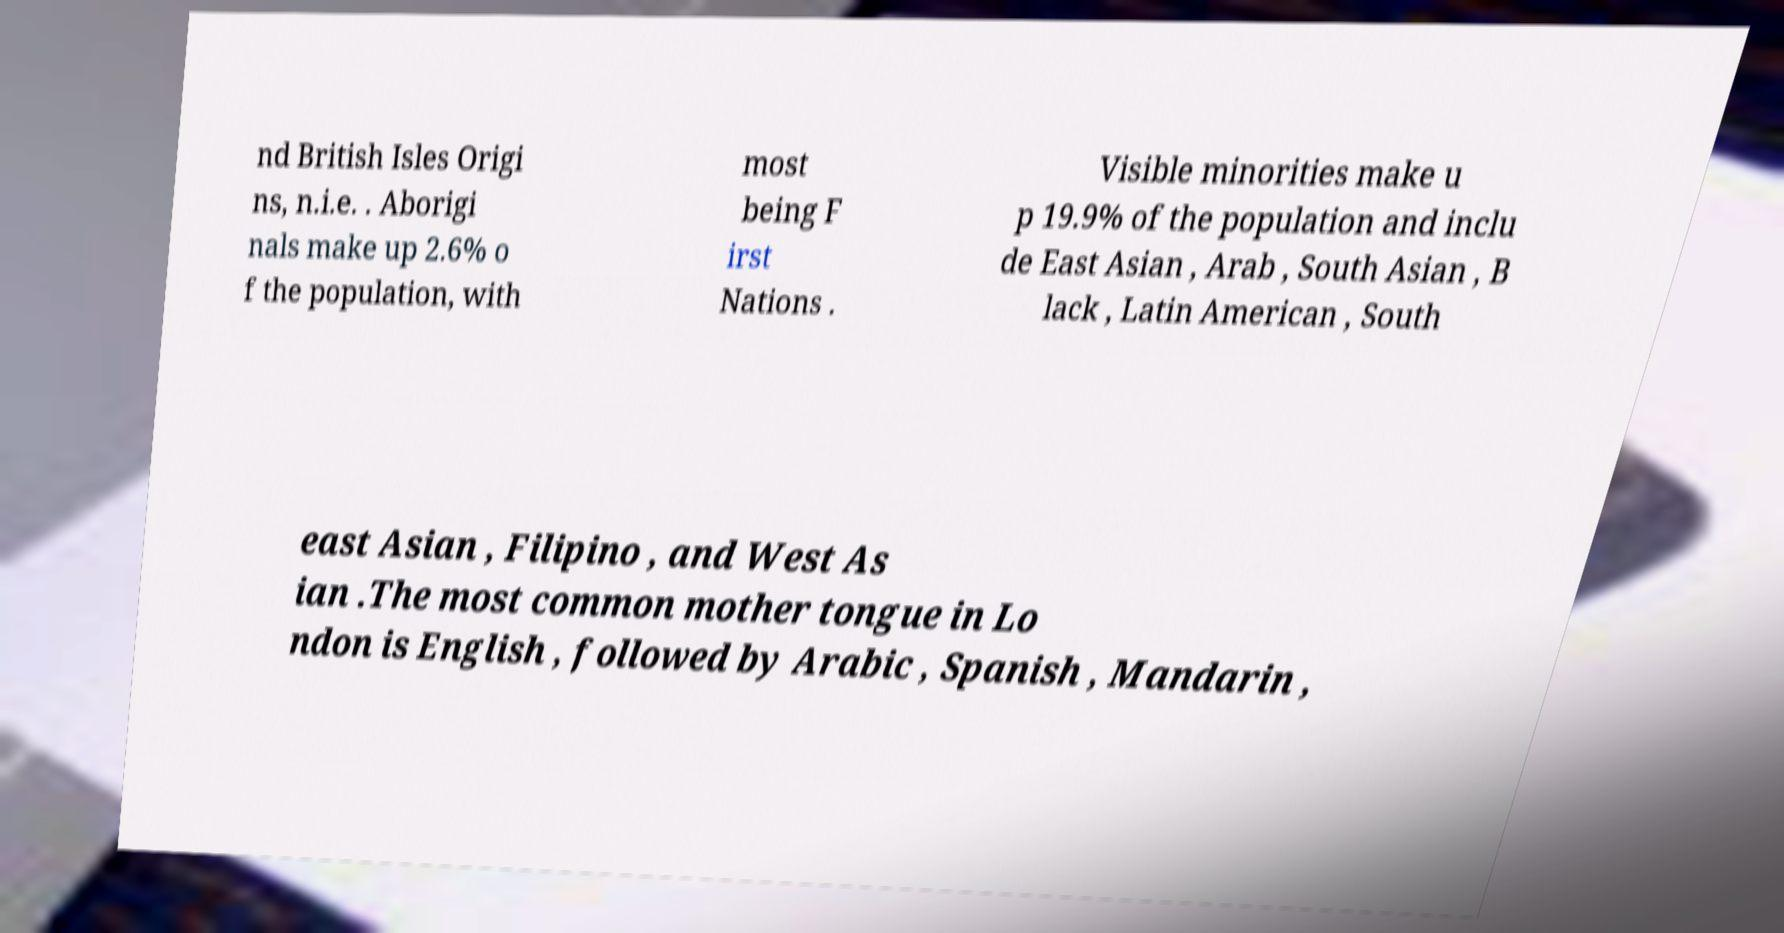What messages or text are displayed in this image? I need them in a readable, typed format. nd British Isles Origi ns, n.i.e. . Aborigi nals make up 2.6% o f the population, with most being F irst Nations . Visible minorities make u p 19.9% of the population and inclu de East Asian , Arab , South Asian , B lack , Latin American , South east Asian , Filipino , and West As ian .The most common mother tongue in Lo ndon is English , followed by Arabic , Spanish , Mandarin , 